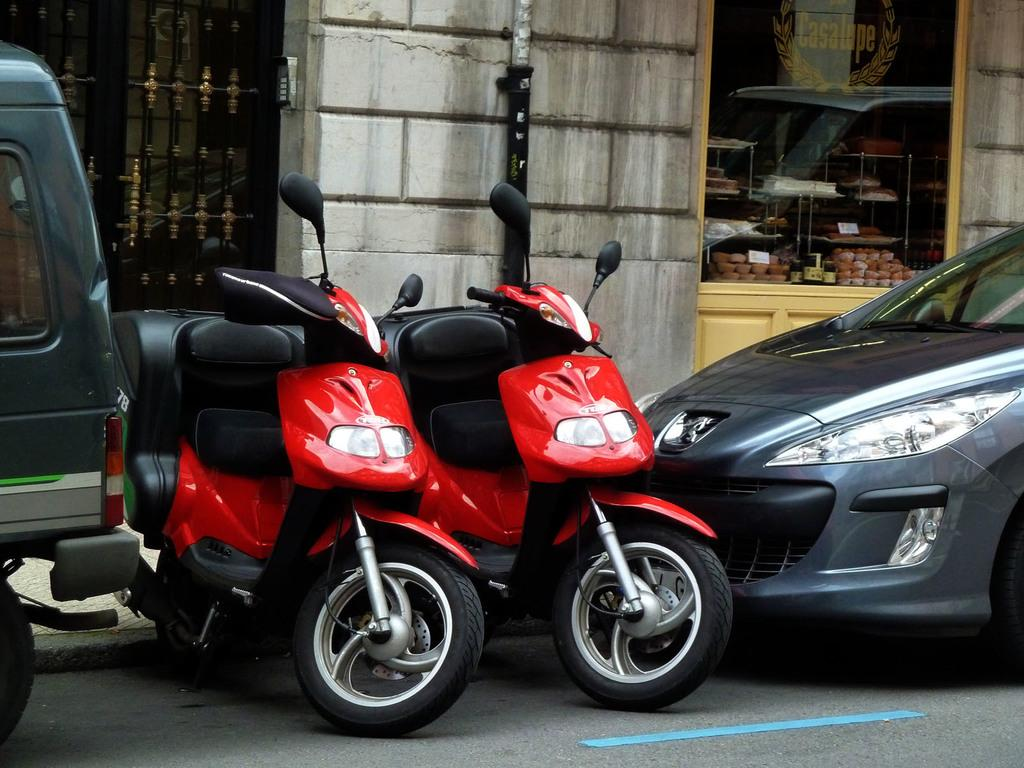What type of vehicles can be seen on the road in the image? There are bikes and cars on the road in the image. What is visible in the background of the image? There is a wall and a glass in the background. What can be seen through the glass? Food items are visible through the glass. Can you see a toad tied in a knot on the spring in the image? There is no toad, knot, or spring present in the image. 